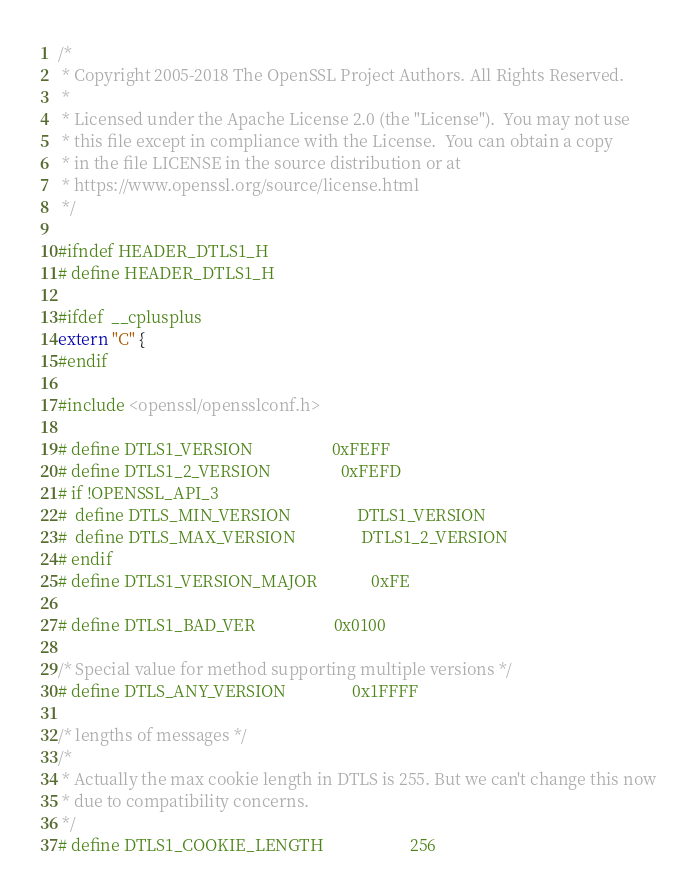Convert code to text. <code><loc_0><loc_0><loc_500><loc_500><_C_>/*
 * Copyright 2005-2018 The OpenSSL Project Authors. All Rights Reserved.
 *
 * Licensed under the Apache License 2.0 (the "License").  You may not use
 * this file except in compliance with the License.  You can obtain a copy
 * in the file LICENSE in the source distribution or at
 * https://www.openssl.org/source/license.html
 */

#ifndef HEADER_DTLS1_H
# define HEADER_DTLS1_H

#ifdef  __cplusplus
extern "C" {
#endif

#include <openssl/opensslconf.h>

# define DTLS1_VERSION                   0xFEFF
# define DTLS1_2_VERSION                 0xFEFD
# if !OPENSSL_API_3
#  define DTLS_MIN_VERSION                DTLS1_VERSION
#  define DTLS_MAX_VERSION                DTLS1_2_VERSION
# endif
# define DTLS1_VERSION_MAJOR             0xFE

# define DTLS1_BAD_VER                   0x0100

/* Special value for method supporting multiple versions */
# define DTLS_ANY_VERSION                0x1FFFF

/* lengths of messages */
/*
 * Actually the max cookie length in DTLS is 255. But we can't change this now
 * due to compatibility concerns.
 */
# define DTLS1_COOKIE_LENGTH                     256
</code> 